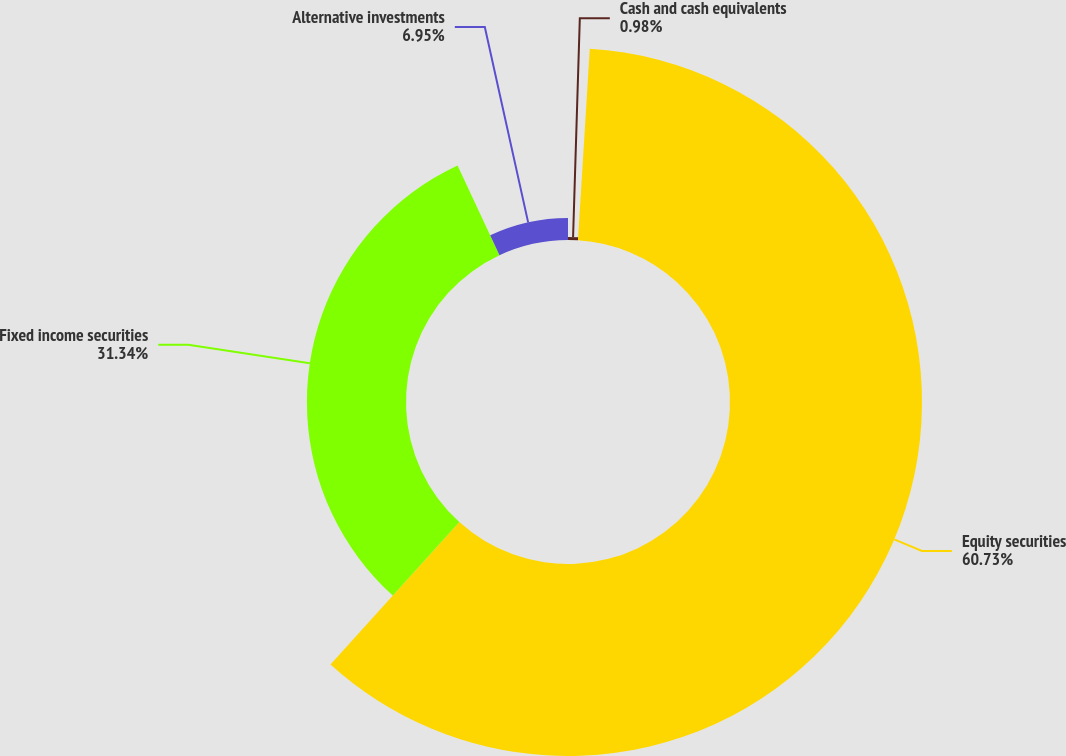Convert chart. <chart><loc_0><loc_0><loc_500><loc_500><pie_chart><fcel>Cash and cash equivalents<fcel>Equity securities<fcel>Fixed income securities<fcel>Alternative investments<nl><fcel>0.98%<fcel>60.72%<fcel>31.34%<fcel>6.95%<nl></chart> 